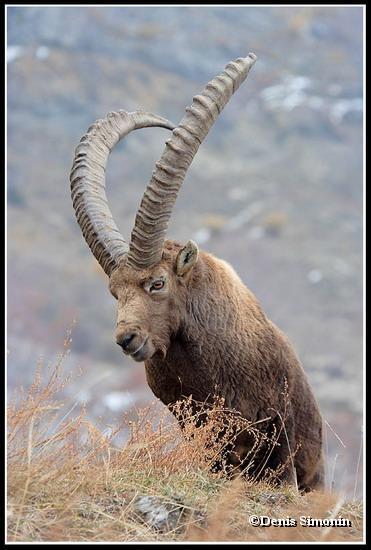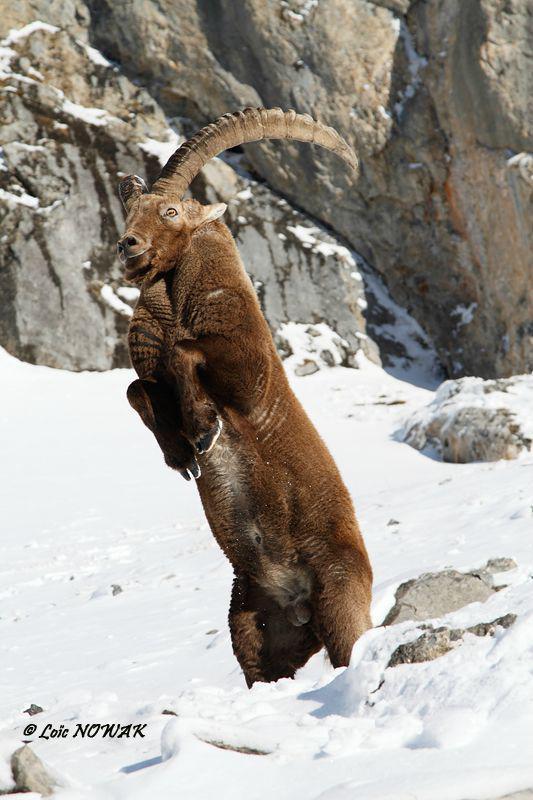The first image is the image on the left, the second image is the image on the right. Assess this claim about the two images: "At least one animal with large upright horns on its head is in a snowy area.". Correct or not? Answer yes or no. Yes. 